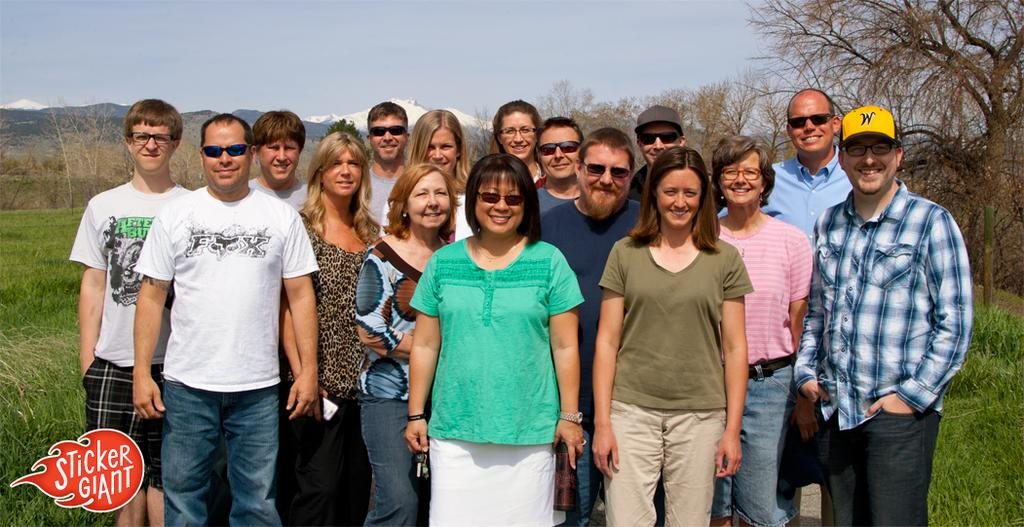How many people are visible in the image? There are many people standing in the image. What protective gear are some people wearing? Some people are wearing goggles and caps. What can be seen in the background of the image? There is grass, trees, and the sky visible in the background of the image. Is there any text or logo present in the image? Yes, there is a watermark in the left corner of the image. Can you tell me how many questions the crow is asking in the image? There is no crow present in the image, and therefore no questions can be attributed to it. 